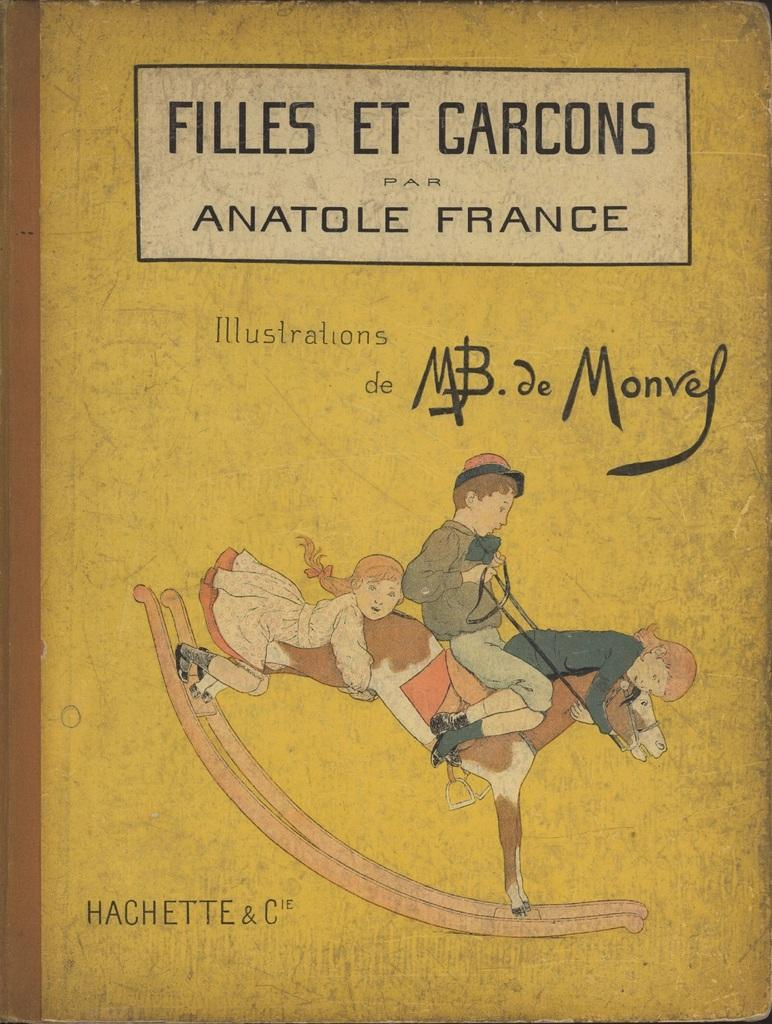<image>
Offer a succinct explanation of the picture presented. A yellow children's book called Filles Et Garcons shows to children riding a horse. 